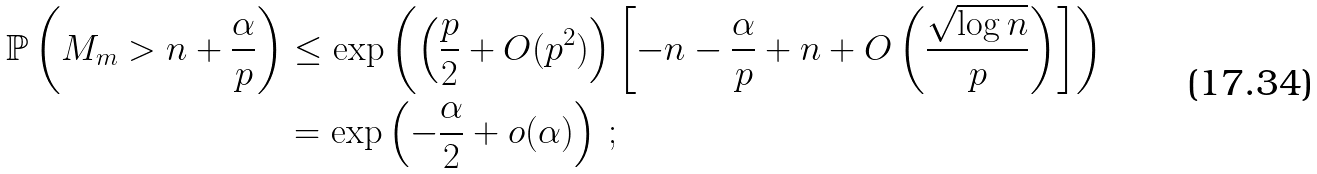Convert formula to latex. <formula><loc_0><loc_0><loc_500><loc_500>\mathbb { P } \left ( M _ { m } > n + \frac { \alpha } { p } \right ) & \leq \exp \left ( \left ( \frac { p } { 2 } + O ( p ^ { 2 } ) \right ) \left [ - n - \frac { \alpha } { p } + n + O \left ( \frac { \sqrt { \log n } } { p } \right ) \right ] \right ) \\ & = \exp \left ( - \frac { \alpha } { 2 } + o ( \alpha ) \right ) \, ;</formula> 